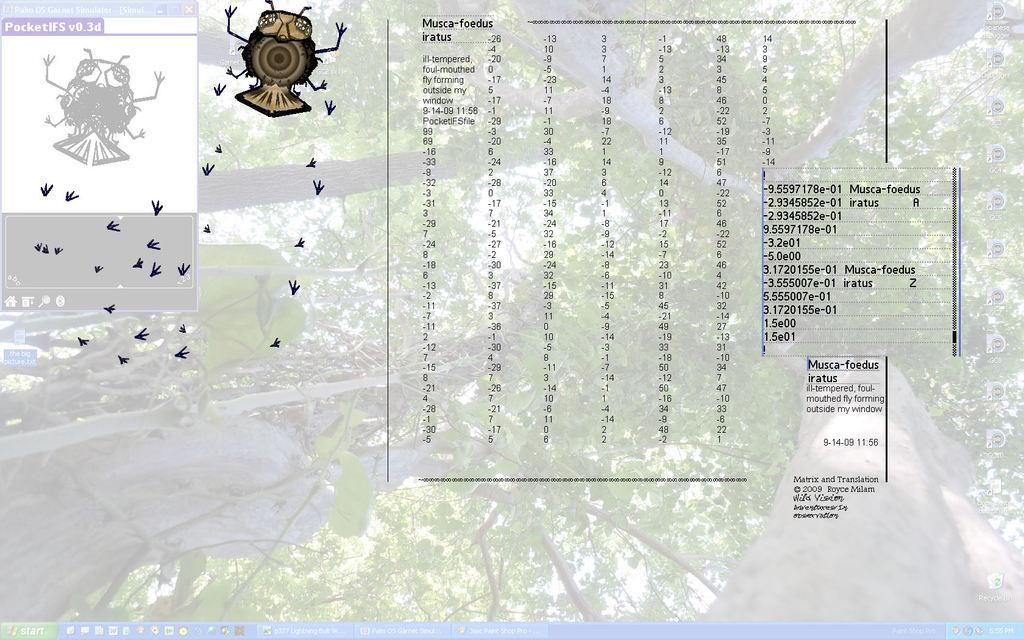What is the main subject of the image? The main subject of the image is a monitor screen. What can be found at the bottom of the screen? There are icons at the bottom of the screen. What type of natural scenery is visible in the image? There are trees visible in the image. What type of information is present on the screen? There is text present in the image. What type of small creature can be seen in the image? There is an insect in the image. How many apples are hanging from the trees in the image? There are no apples visible in the image; only trees are present in the background. What type of ticket can be seen on the monitor screen? There is no ticket present on the monitor screen; the image only shows a screen with icons, text, and an insect. 